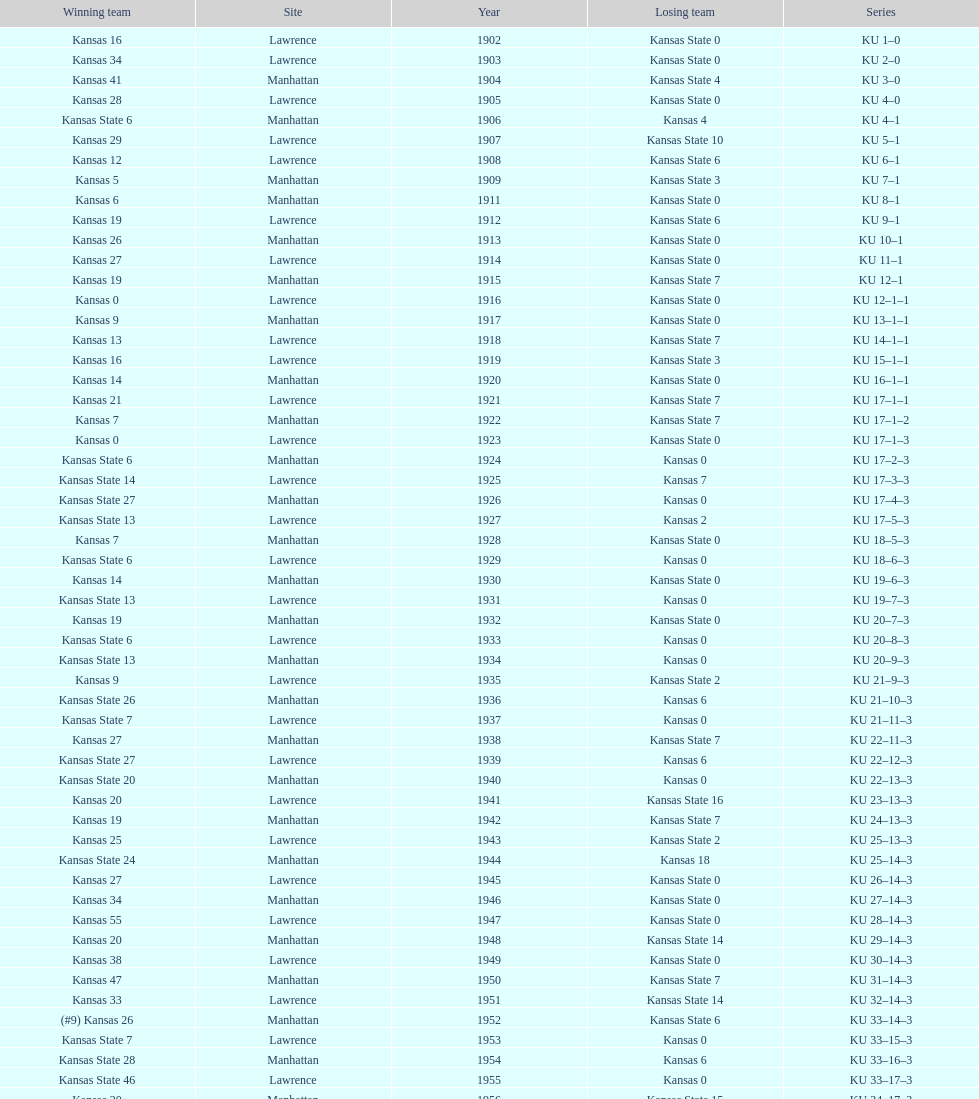When was the first game that kansas state won by double digits? 1926. 